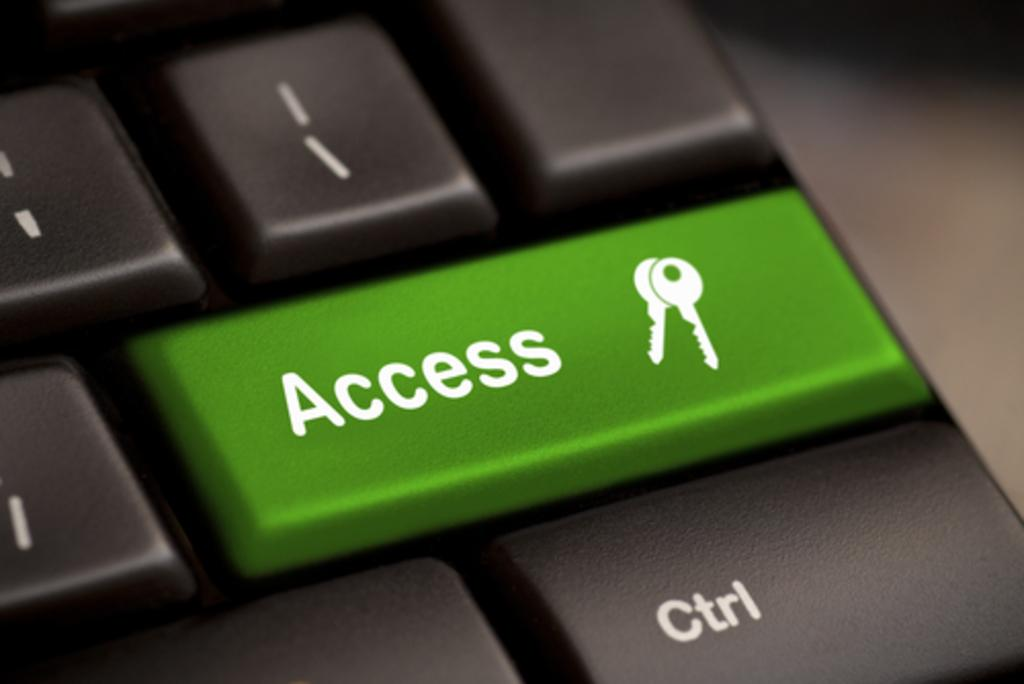<image>
Write a terse but informative summary of the picture. A green access key on an otherwise black keyboard. 